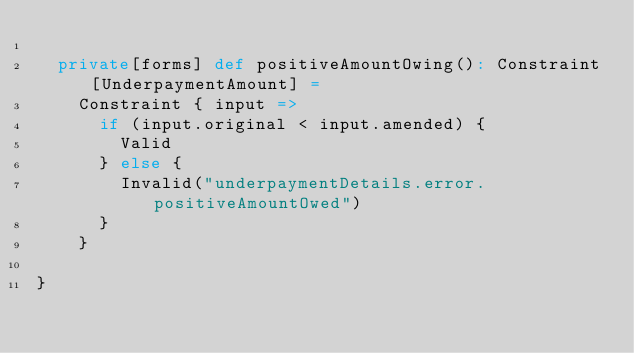Convert code to text. <code><loc_0><loc_0><loc_500><loc_500><_Scala_>
  private[forms] def positiveAmountOwing(): Constraint[UnderpaymentAmount] =
    Constraint { input =>
      if (input.original < input.amended) {
        Valid
      } else {
        Invalid("underpaymentDetails.error.positiveAmountOwed")
      }
    }

}
</code> 